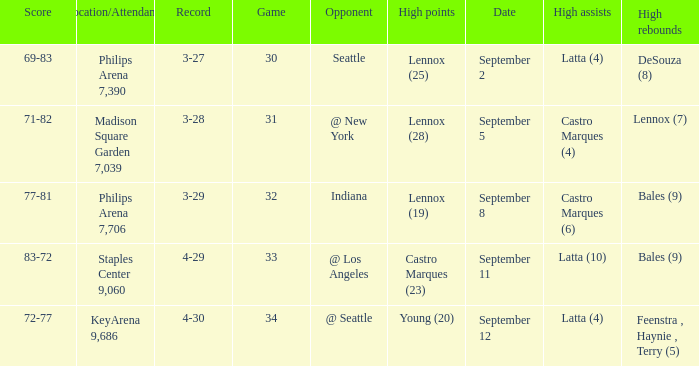When did indiana play? September 8. 